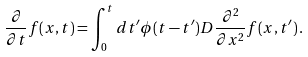<formula> <loc_0><loc_0><loc_500><loc_500>\frac { \partial } { \partial t } f ( x , t ) = \int _ { 0 } ^ { t } d t ^ { \prime } \phi ( t - t ^ { \prime } ) D \frac { \partial ^ { 2 } } { \partial x ^ { 2 } } f ( x , t ^ { \prime } ) \, .</formula> 